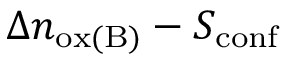<formula> <loc_0><loc_0><loc_500><loc_500>\Delta n _ { o x ( B ) } - S _ { c o n f }</formula> 